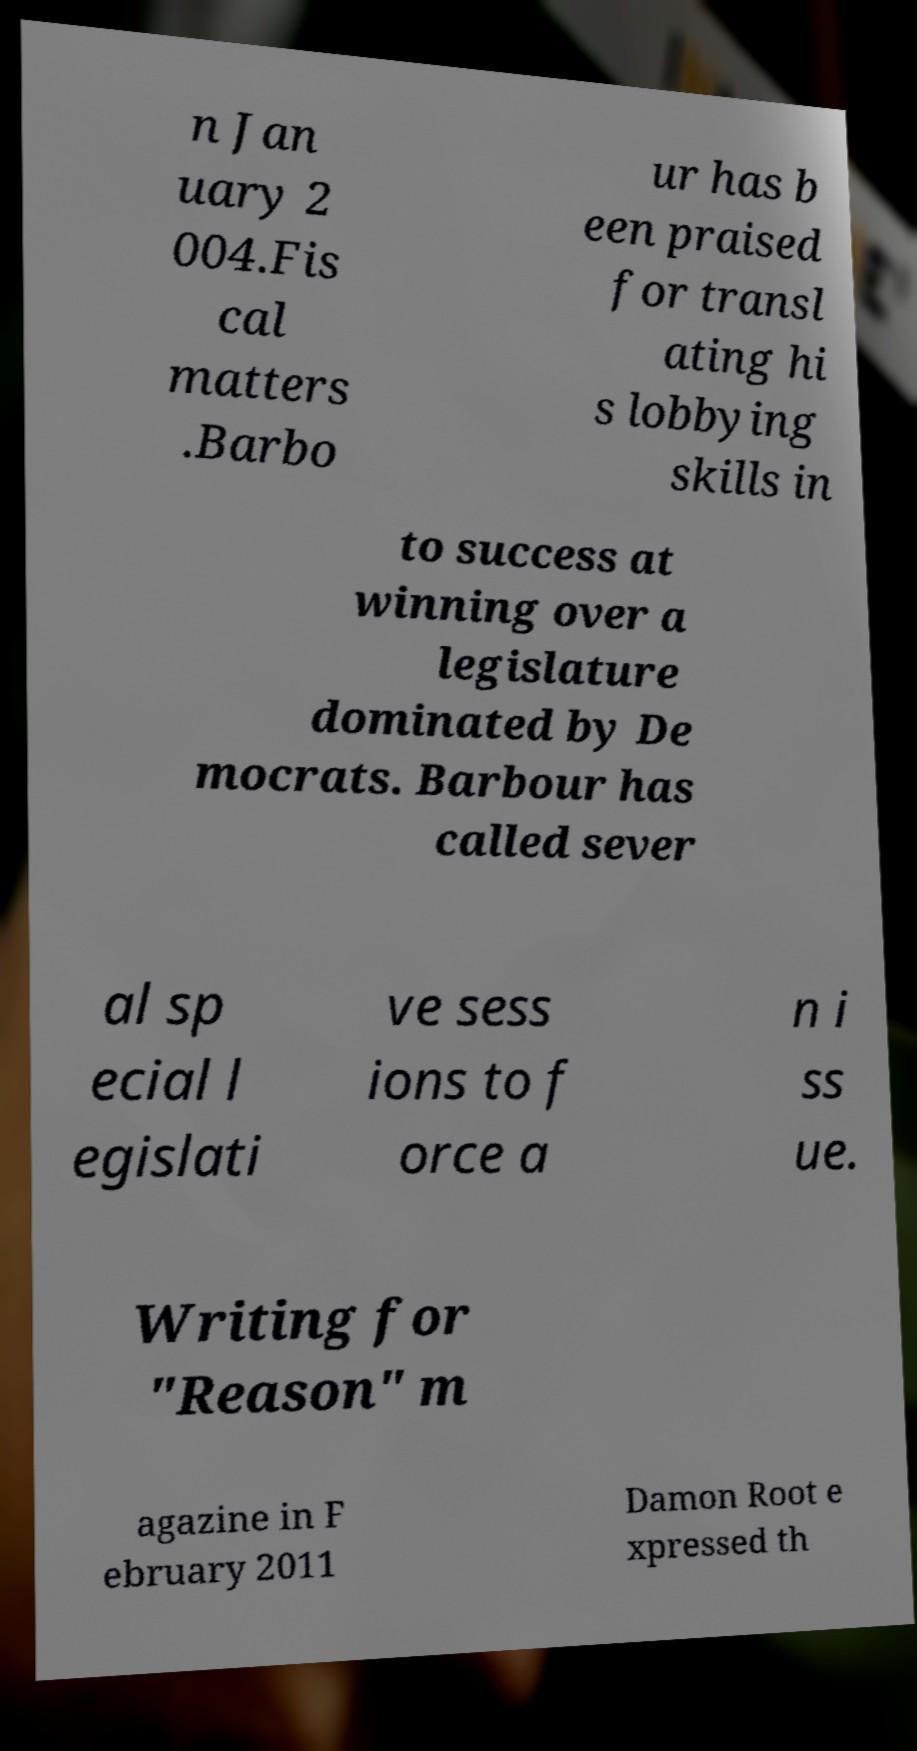Could you assist in decoding the text presented in this image and type it out clearly? n Jan uary 2 004.Fis cal matters .Barbo ur has b een praised for transl ating hi s lobbying skills in to success at winning over a legislature dominated by De mocrats. Barbour has called sever al sp ecial l egislati ve sess ions to f orce a n i ss ue. Writing for "Reason" m agazine in F ebruary 2011 Damon Root e xpressed th 